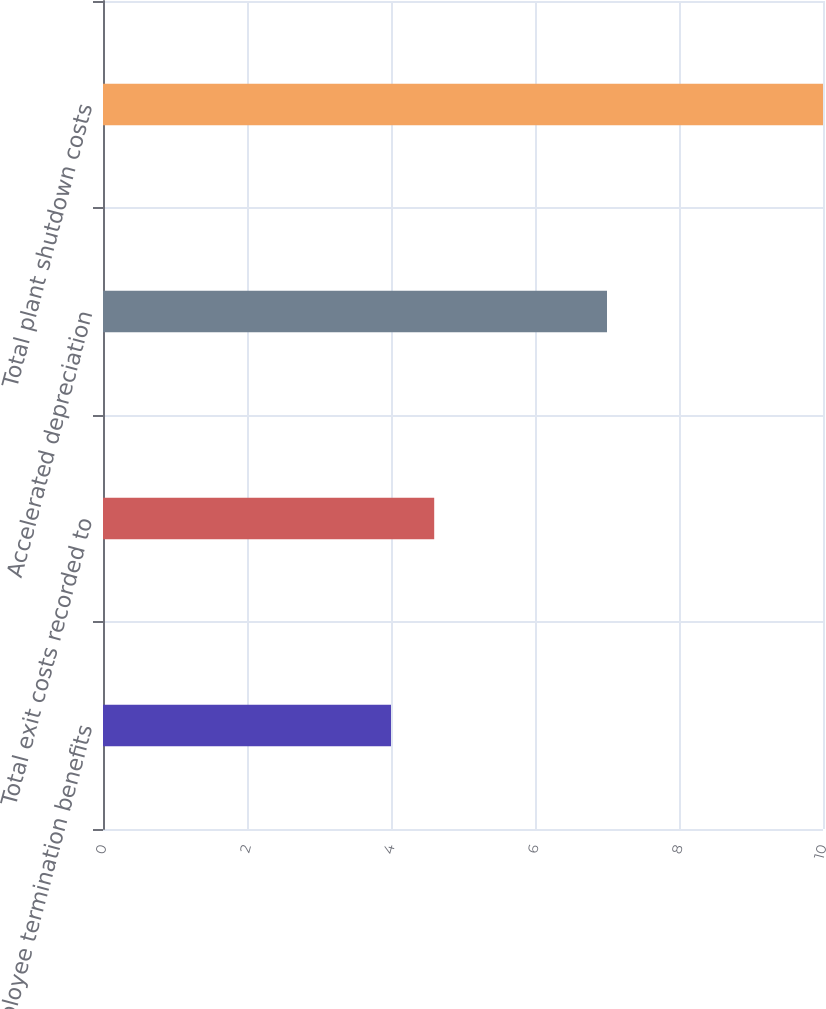Convert chart to OTSL. <chart><loc_0><loc_0><loc_500><loc_500><bar_chart><fcel>Employee termination benefits<fcel>Total exit costs recorded to<fcel>Accelerated depreciation<fcel>Total plant shutdown costs<nl><fcel>4<fcel>4.6<fcel>7<fcel>10<nl></chart> 